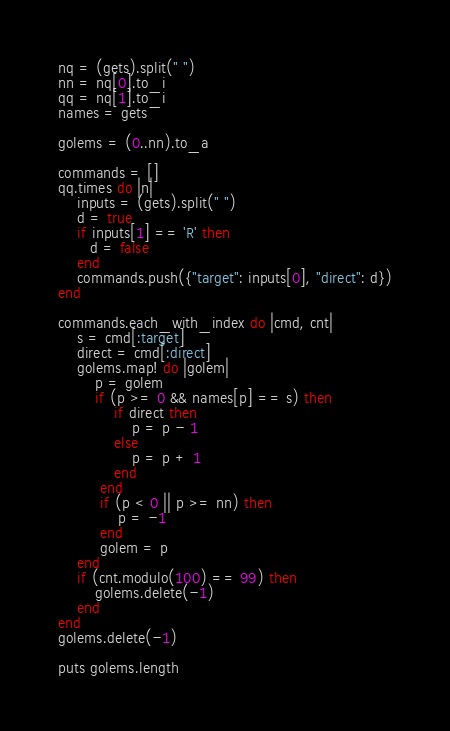Convert code to text. <code><loc_0><loc_0><loc_500><loc_500><_Ruby_>nq = (gets).split(" ")
nn = nq[0].to_i
qq = nq[1].to_i
names = gets

golems = (0..nn).to_a

commands = []
qq.times do |n|
    inputs = (gets).split(" ")
    d = true
    if inputs[1] == 'R' then
       d = false
    end
    commands.push({"target": inputs[0], "direct": d})
end

commands.each_with_index do |cmd, cnt|
    s = cmd[:target]
    direct = cmd[:direct]
    golems.map! do |golem|
        p = golem
        if (p >= 0 && names[p] == s) then
            if direct then
                p = p - 1
            else
                p = p + 1
            end
         end
         if (p < 0 || p >= nn) then
             p = -1
         end
         golem = p
    end
    if (cnt.modulo(100) == 99) then
        golems.delete(-1)
    end
end
golems.delete(-1)

puts golems.length</code> 